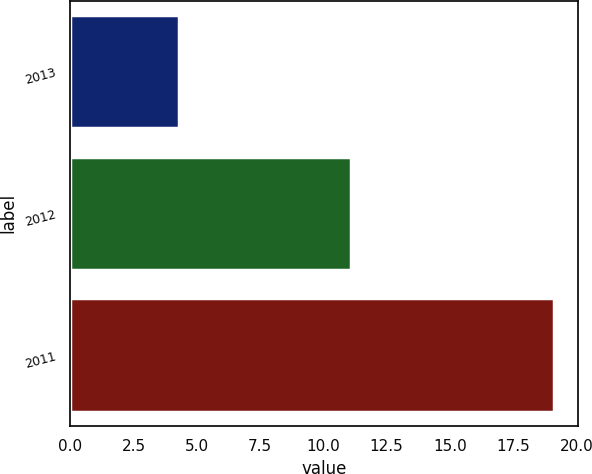<chart> <loc_0><loc_0><loc_500><loc_500><bar_chart><fcel>2013<fcel>2012<fcel>2011<nl><fcel>4.3<fcel>11.1<fcel>19.1<nl></chart> 